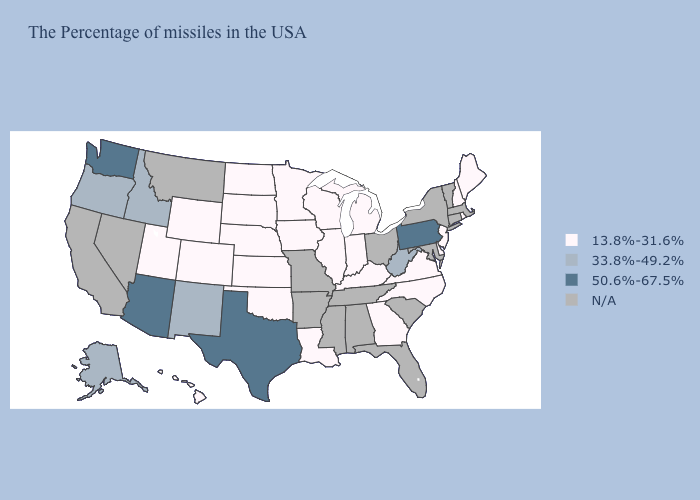What is the value of Alabama?
Keep it brief. N/A. What is the lowest value in the West?
Concise answer only. 13.8%-31.6%. Name the states that have a value in the range 50.6%-67.5%?
Answer briefly. Pennsylvania, Texas, Arizona, Washington. What is the highest value in the West ?
Concise answer only. 50.6%-67.5%. Name the states that have a value in the range 13.8%-31.6%?
Be succinct. Maine, Rhode Island, New Hampshire, New Jersey, Delaware, Virginia, North Carolina, Georgia, Michigan, Kentucky, Indiana, Wisconsin, Illinois, Louisiana, Minnesota, Iowa, Kansas, Nebraska, Oklahoma, South Dakota, North Dakota, Wyoming, Colorado, Utah, Hawaii. Is the legend a continuous bar?
Be succinct. No. Name the states that have a value in the range 33.8%-49.2%?
Keep it brief. West Virginia, New Mexico, Idaho, Oregon, Alaska. Does the first symbol in the legend represent the smallest category?
Be succinct. Yes. Is the legend a continuous bar?
Quick response, please. No. What is the lowest value in the USA?
Concise answer only. 13.8%-31.6%. Does the map have missing data?
Write a very short answer. Yes. Does Virginia have the highest value in the South?
Short answer required. No. Name the states that have a value in the range 50.6%-67.5%?
Write a very short answer. Pennsylvania, Texas, Arizona, Washington. 